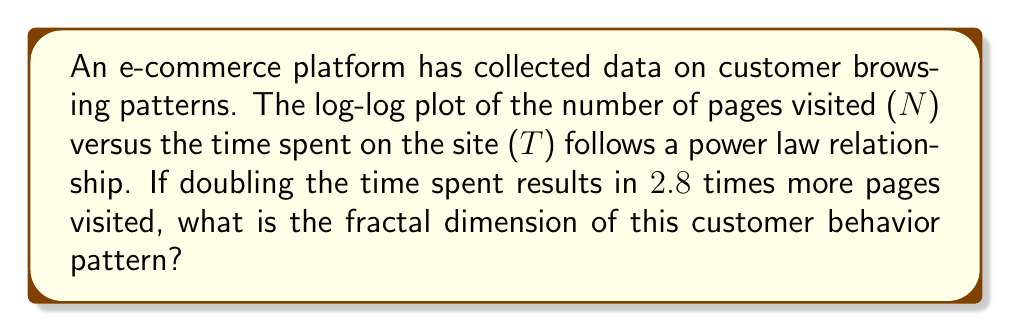Give your solution to this math problem. Let's approach this step-by-step:

1) The power law relationship between N and T can be expressed as:

   $$N \propto T^D$$

   where D is the fractal dimension we're looking for.

2) In log-log scale, this becomes a linear relationship:

   $$\log N = D \log T + \text{constant}$$

3) We're told that doubling T results in 2.8 times more N. Let's express this mathematically:

   $$\frac{N(2T)}{N(T)} = 2.8$$

4) Using the power law relationship:

   $$\frac{(2T)^D}{T^D} = 2.8$$

5) Simplify:

   $$2^D = 2.8$$

6) Take the logarithm of both sides:

   $$D \log 2 = \log 2.8$$

7) Solve for D:

   $$D = \frac{\log 2.8}{\log 2}$$

8) Calculate:

   $$D \approx 1.4854$$

This fractal dimension (1.4854) indicates a pattern between a line (dimension 1) and a plane (dimension 2), suggesting complex but not entirely random customer behavior.
Answer: $$D \approx 1.4854$$ 